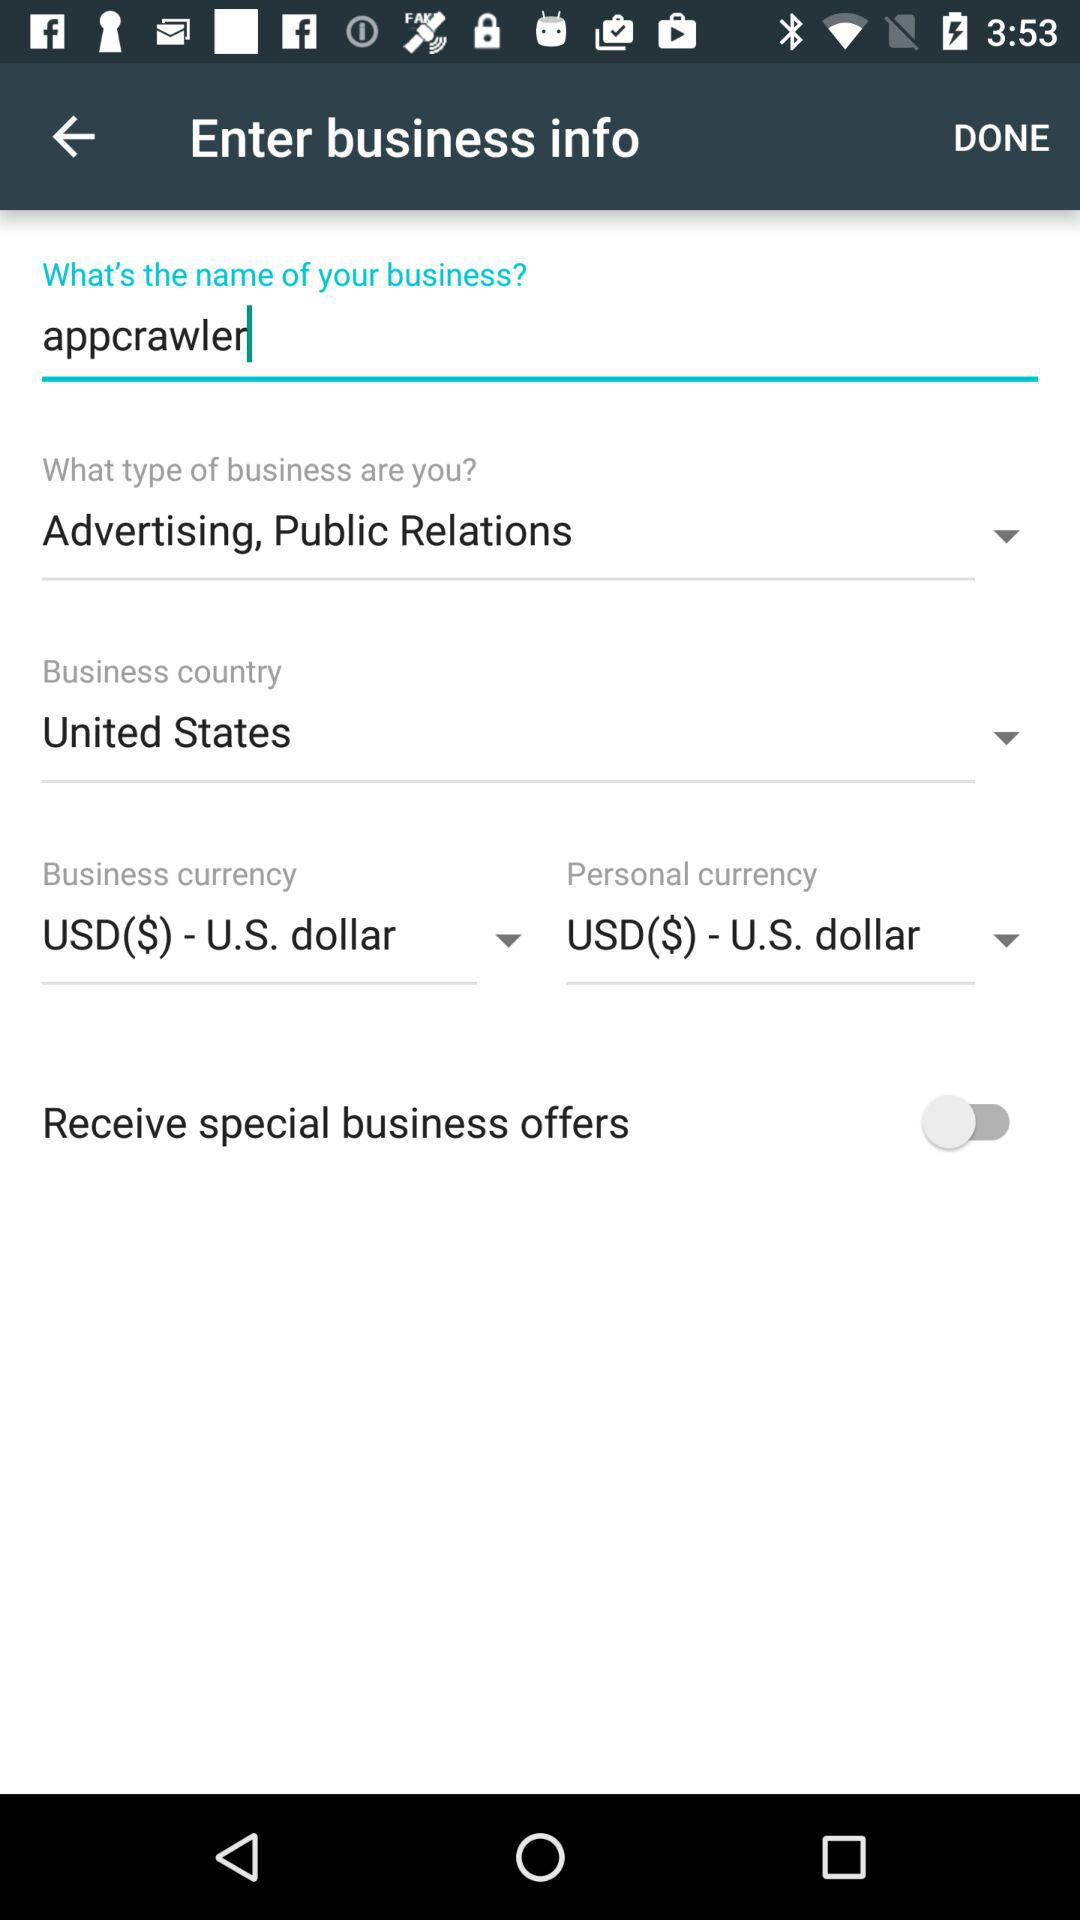What is the selected currency for business? The selected currency for business is "USD($) - U.S. dollar". 